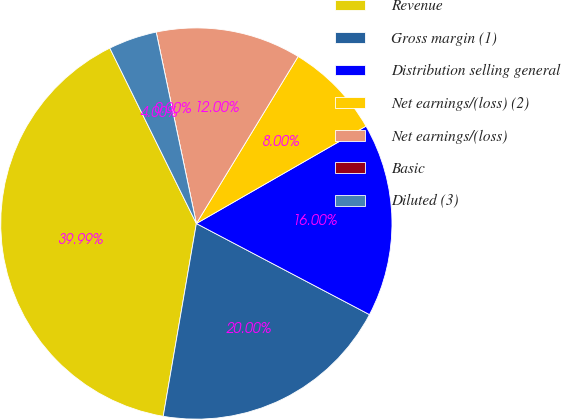Convert chart. <chart><loc_0><loc_0><loc_500><loc_500><pie_chart><fcel>Revenue<fcel>Gross margin (1)<fcel>Distribution selling general<fcel>Net earnings/(loss) (2)<fcel>Net earnings/(loss)<fcel>Basic<fcel>Diluted (3)<nl><fcel>39.99%<fcel>20.0%<fcel>16.0%<fcel>8.0%<fcel>12.0%<fcel>0.0%<fcel>4.0%<nl></chart> 